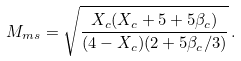<formula> <loc_0><loc_0><loc_500><loc_500>M _ { m s } = \sqrt { \frac { X _ { c } ( X _ { c } + 5 + 5 \beta _ { c } ) } { ( 4 - X _ { c } ) ( 2 + 5 \beta _ { c } / 3 ) } } \, .</formula> 